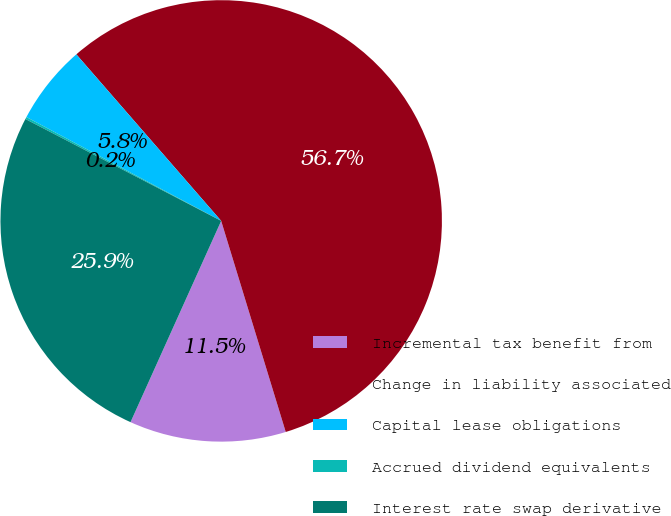Convert chart. <chart><loc_0><loc_0><loc_500><loc_500><pie_chart><fcel>Incremental tax benefit from<fcel>Change in liability associated<fcel>Capital lease obligations<fcel>Accrued dividend equivalents<fcel>Interest rate swap derivative<nl><fcel>11.46%<fcel>56.67%<fcel>5.81%<fcel>0.16%<fcel>25.9%<nl></chart> 